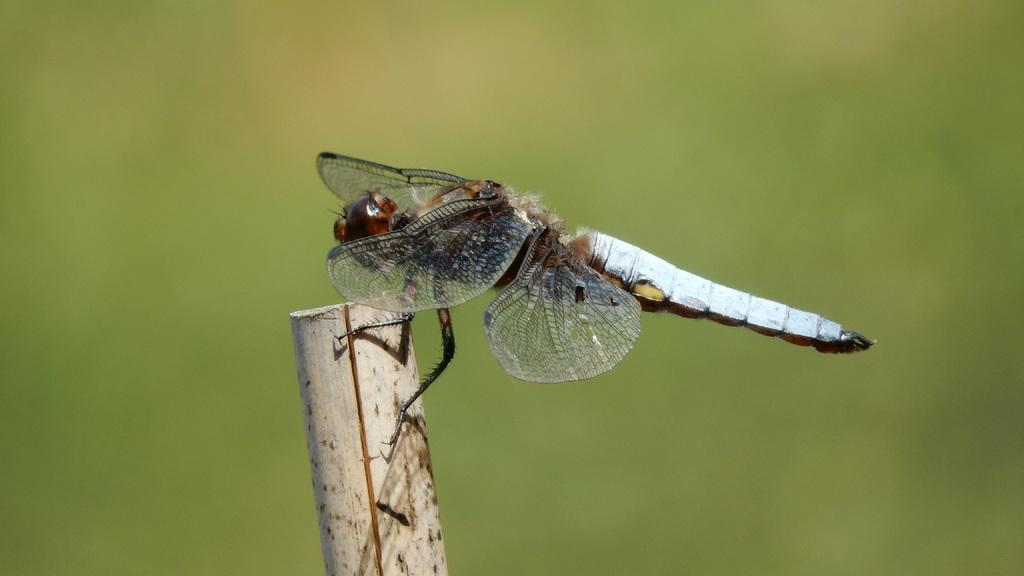What type of creature can be seen in the image? There is an insect in the image. What is the insect sitting on? The insect is sitting on a wooden object. Can you describe the background of the image? The background of the image is blurred. What color is the twist in the image? There is no twist present in the image. 